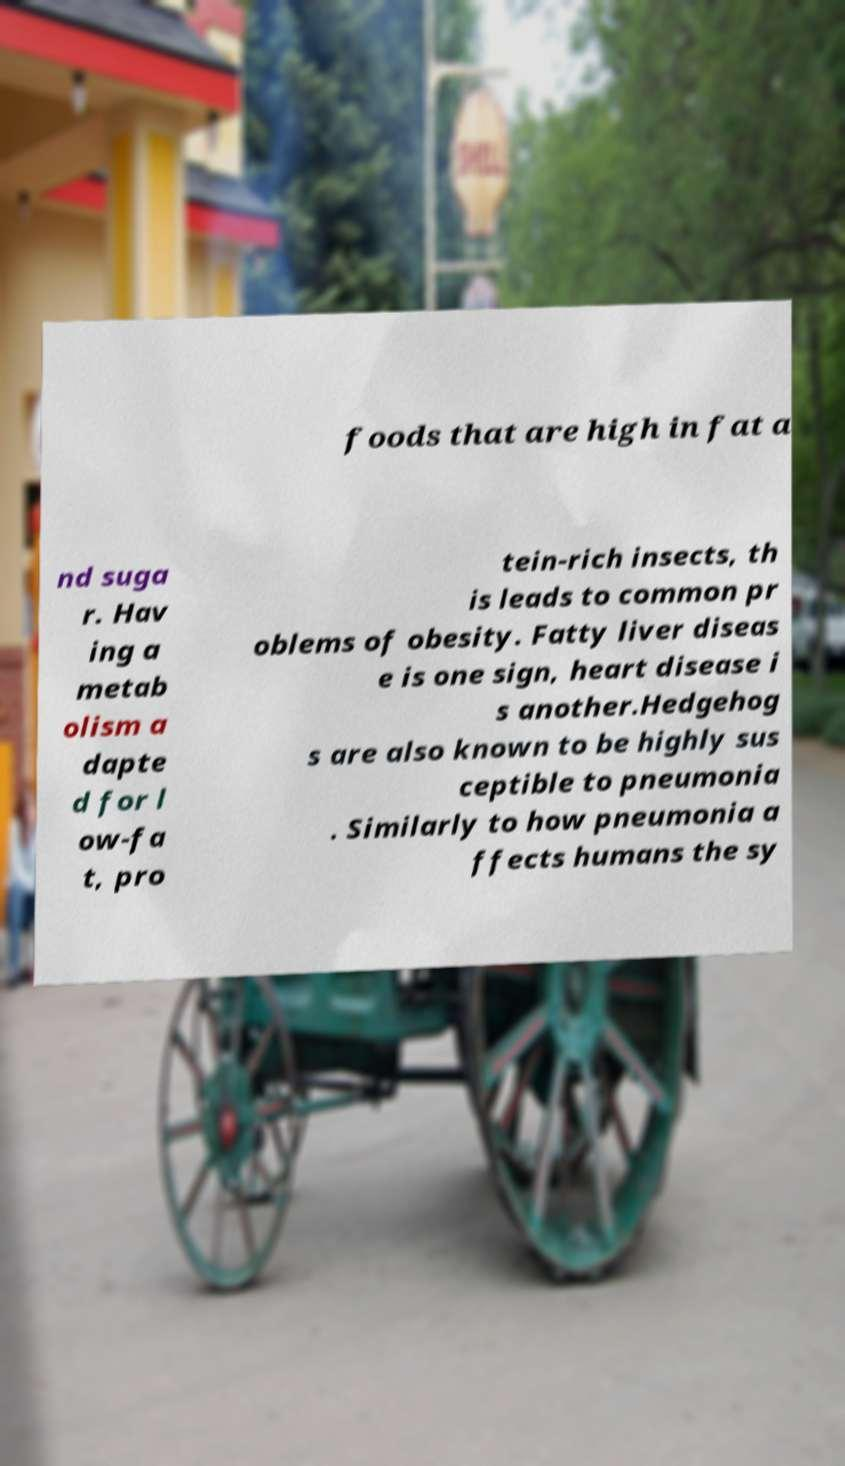For documentation purposes, I need the text within this image transcribed. Could you provide that? foods that are high in fat a nd suga r. Hav ing a metab olism a dapte d for l ow-fa t, pro tein-rich insects, th is leads to common pr oblems of obesity. Fatty liver diseas e is one sign, heart disease i s another.Hedgehog s are also known to be highly sus ceptible to pneumonia . Similarly to how pneumonia a ffects humans the sy 